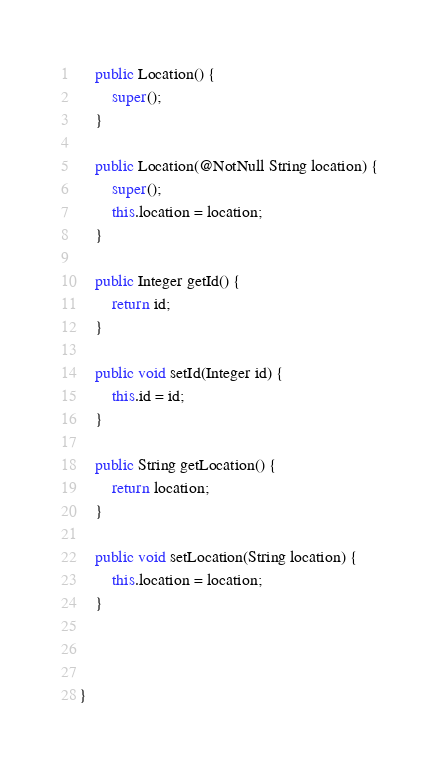<code> <loc_0><loc_0><loc_500><loc_500><_Java_>	public Location() {
		super();
	}

	public Location(@NotNull String location) {
		super();
		this.location = location;
	}

	public Integer getId() {
		return id;
	}

	public void setId(Integer id) {
		this.id = id;
	}

	public String getLocation() {
		return location;
	}

	public void setLocation(String location) {
		this.location = location;
	}
	


}
</code> 